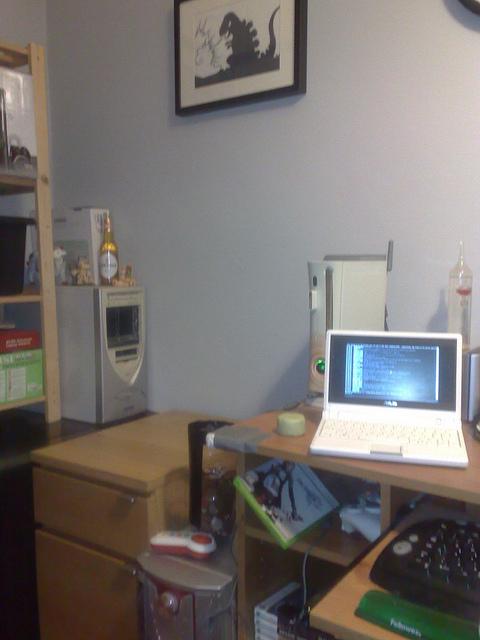Are these all apple computers?
Quick response, please. No. Could this be a home school?
Be succinct. Yes. How many pictures are on the wall?
Answer briefly. 1. Whose picture is on the wall?
Give a very brief answer. Dinosaur. What color is the wall?
Give a very brief answer. White. Does it look like this room is in the middle of an improvement project?
Concise answer only. No. How many computer screens are on?
Give a very brief answer. 1. What type of DVD is setting on the desk?
Be succinct. Video game. What color is the picture frame?
Concise answer only. Black. How many keyboards are they?
Answer briefly. 2. What is the green item?
Give a very brief answer. Mouse pad. What is the desktop made out of?
Concise answer only. Wood. What is visible at the top of the image?
Answer briefly. Picture. Where is the computer tower?
Write a very short answer. Left. What color are the walls?
Write a very short answer. White. How many computers are in the room?
Write a very short answer. 1. What is the picture of?
Concise answer only. Laptop. How many monitors are on?
Keep it brief. 1. What is in the bottom drawer?
Concise answer only. Books. Is this an office desk?
Answer briefly. Yes. Is this a computer workshop?
Answer briefly. No. 